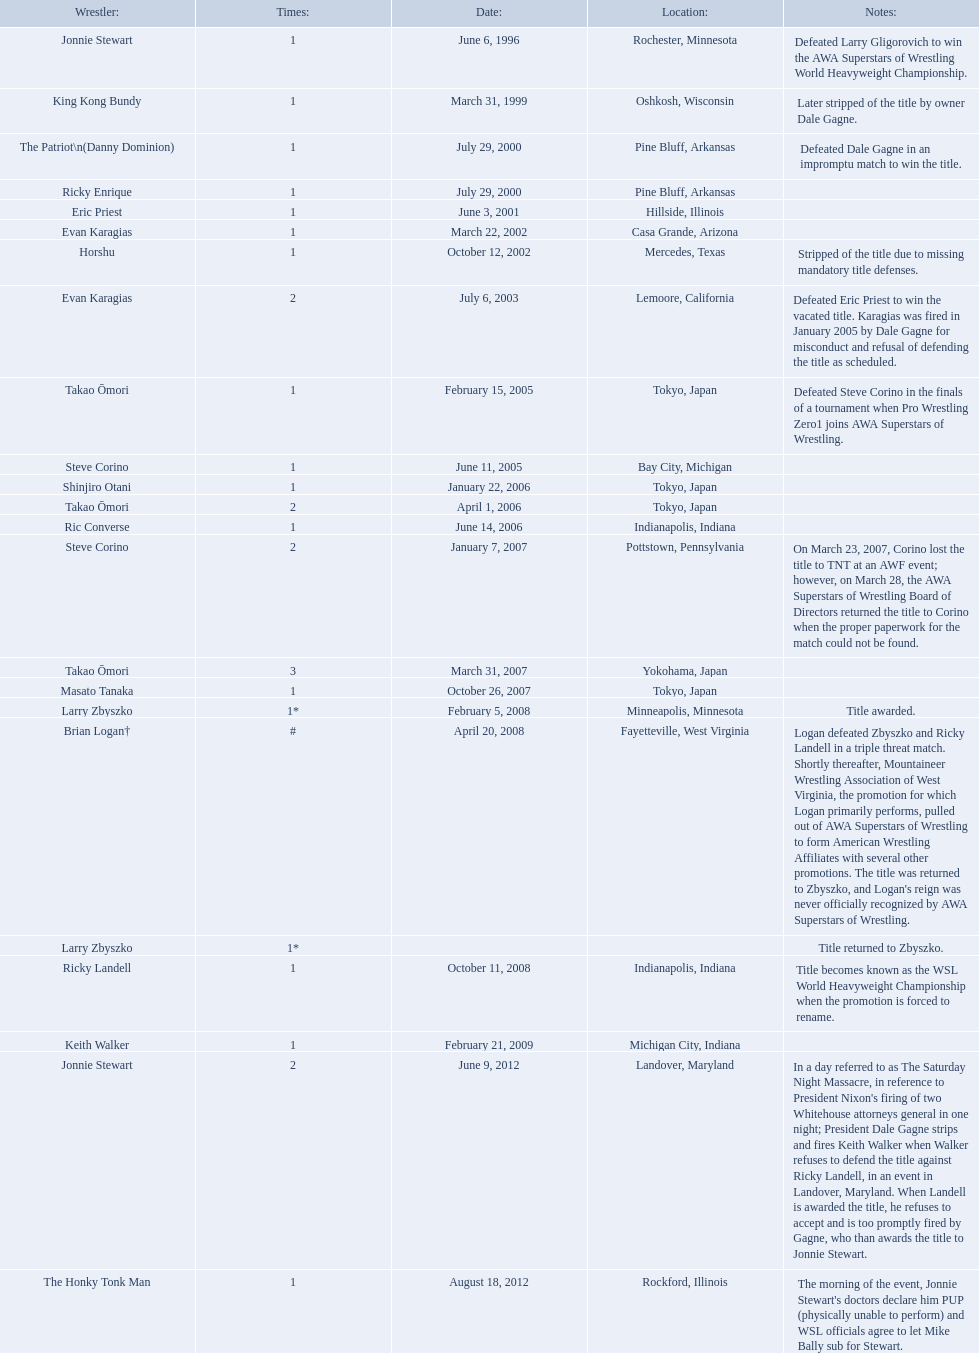Who are the wrestlers? Jonnie Stewart, Rochester, Minnesota, King Kong Bundy, Oshkosh, Wisconsin, The Patriot\n(Danny Dominion), Pine Bluff, Arkansas, Ricky Enrique, Pine Bluff, Arkansas, Eric Priest, Hillside, Illinois, Evan Karagias, Casa Grande, Arizona, Horshu, Mercedes, Texas, Evan Karagias, Lemoore, California, Takao Ōmori, Tokyo, Japan, Steve Corino, Bay City, Michigan, Shinjiro Otani, Tokyo, Japan, Takao Ōmori, Tokyo, Japan, Ric Converse, Indianapolis, Indiana, Steve Corino, Pottstown, Pennsylvania, Takao Ōmori, Yokohama, Japan, Masato Tanaka, Tokyo, Japan, Larry Zbyszko, Minneapolis, Minnesota, Brian Logan†, Fayetteville, West Virginia, Larry Zbyszko, , Ricky Landell, Indianapolis, Indiana, Keith Walker, Michigan City, Indiana, Jonnie Stewart, Landover, Maryland, The Honky Tonk Man, Rockford, Illinois. Who was from texas? Horshu, Mercedes, Texas. I'm looking to parse the entire table for insights. Could you assist me with that? {'header': ['Wrestler:', 'Times:', 'Date:', 'Location:', 'Notes:'], 'rows': [['Jonnie Stewart', '1', 'June 6, 1996', 'Rochester, Minnesota', 'Defeated Larry Gligorovich to win the AWA Superstars of Wrestling World Heavyweight Championship.'], ['King Kong Bundy', '1', 'March 31, 1999', 'Oshkosh, Wisconsin', 'Later stripped of the title by owner Dale Gagne.'], ['The Patriot\\n(Danny Dominion)', '1', 'July 29, 2000', 'Pine Bluff, Arkansas', 'Defeated Dale Gagne in an impromptu match to win the title.'], ['Ricky Enrique', '1', 'July 29, 2000', 'Pine Bluff, Arkansas', ''], ['Eric Priest', '1', 'June 3, 2001', 'Hillside, Illinois', ''], ['Evan Karagias', '1', 'March 22, 2002', 'Casa Grande, Arizona', ''], ['Horshu', '1', 'October 12, 2002', 'Mercedes, Texas', 'Stripped of the title due to missing mandatory title defenses.'], ['Evan Karagias', '2', 'July 6, 2003', 'Lemoore, California', 'Defeated Eric Priest to win the vacated title. Karagias was fired in January 2005 by Dale Gagne for misconduct and refusal of defending the title as scheduled.'], ['Takao Ōmori', '1', 'February 15, 2005', 'Tokyo, Japan', 'Defeated Steve Corino in the finals of a tournament when Pro Wrestling Zero1 joins AWA Superstars of Wrestling.'], ['Steve Corino', '1', 'June 11, 2005', 'Bay City, Michigan', ''], ['Shinjiro Otani', '1', 'January 22, 2006', 'Tokyo, Japan', ''], ['Takao Ōmori', '2', 'April 1, 2006', 'Tokyo, Japan', ''], ['Ric Converse', '1', 'June 14, 2006', 'Indianapolis, Indiana', ''], ['Steve Corino', '2', 'January 7, 2007', 'Pottstown, Pennsylvania', 'On March 23, 2007, Corino lost the title to TNT at an AWF event; however, on March 28, the AWA Superstars of Wrestling Board of Directors returned the title to Corino when the proper paperwork for the match could not be found.'], ['Takao Ōmori', '3', 'March 31, 2007', 'Yokohama, Japan', ''], ['Masato Tanaka', '1', 'October 26, 2007', 'Tokyo, Japan', ''], ['Larry Zbyszko', '1*', 'February 5, 2008', 'Minneapolis, Minnesota', 'Title awarded.'], ['Brian Logan†', '#', 'April 20, 2008', 'Fayetteville, West Virginia', "Logan defeated Zbyszko and Ricky Landell in a triple threat match. Shortly thereafter, Mountaineer Wrestling Association of West Virginia, the promotion for which Logan primarily performs, pulled out of AWA Superstars of Wrestling to form American Wrestling Affiliates with several other promotions. The title was returned to Zbyszko, and Logan's reign was never officially recognized by AWA Superstars of Wrestling."], ['Larry Zbyszko', '1*', '', '', 'Title returned to Zbyszko.'], ['Ricky Landell', '1', 'October 11, 2008', 'Indianapolis, Indiana', 'Title becomes known as the WSL World Heavyweight Championship when the promotion is forced to rename.'], ['Keith Walker', '1', 'February 21, 2009', 'Michigan City, Indiana', ''], ['Jonnie Stewart', '2', 'June 9, 2012', 'Landover, Maryland', "In a day referred to as The Saturday Night Massacre, in reference to President Nixon's firing of two Whitehouse attorneys general in one night; President Dale Gagne strips and fires Keith Walker when Walker refuses to defend the title against Ricky Landell, in an event in Landover, Maryland. When Landell is awarded the title, he refuses to accept and is too promptly fired by Gagne, who than awards the title to Jonnie Stewart."], ['The Honky Tonk Man', '1', 'August 18, 2012', 'Rockford, Illinois', "The morning of the event, Jonnie Stewart's doctors declare him PUP (physically unable to perform) and WSL officials agree to let Mike Bally sub for Stewart."]]} Who is he? Horshu. Who are the grapplers? Jonnie Stewart, Rochester, Minnesota, King Kong Bundy, Oshkosh, Wisconsin, The Patriot\n(Danny Dominion), Pine Bluff, Arkansas, Ricky Enrique, Pine Bluff, Arkansas, Eric Priest, Hillside, Illinois, Evan Karagias, Casa Grande, Arizona, Horshu, Mercedes, Texas, Evan Karagias, Lemoore, California, Takao Ōmori, Tokyo, Japan, Steve Corino, Bay City, Michigan, Shinjiro Otani, Tokyo, Japan, Takao Ōmori, Tokyo, Japan, Ric Converse, Indianapolis, Indiana, Steve Corino, Pottstown, Pennsylvania, Takao Ōmori, Yokohama, Japan, Masato Tanaka, Tokyo, Japan, Larry Zbyszko, Minneapolis, Minnesota, Brian Logan†, Fayetteville, West Virginia, Larry Zbyszko, , Ricky Landell, Indianapolis, Indiana, Keith Walker, Michigan City, Indiana, Jonnie Stewart, Landover, Maryland, The Honky Tonk Man, Rockford, Illinois. Who was from texas? Horshu, Mercedes, Texas. Who is he? Horshu. Who are the wrestling participants? Jonnie Stewart, Rochester, Minnesota, King Kong Bundy, Oshkosh, Wisconsin, The Patriot\n(Danny Dominion), Pine Bluff, Arkansas, Ricky Enrique, Pine Bluff, Arkansas, Eric Priest, Hillside, Illinois, Evan Karagias, Casa Grande, Arizona, Horshu, Mercedes, Texas, Evan Karagias, Lemoore, California, Takao Ōmori, Tokyo, Japan, Steve Corino, Bay City, Michigan, Shinjiro Otani, Tokyo, Japan, Takao Ōmori, Tokyo, Japan, Ric Converse, Indianapolis, Indiana, Steve Corino, Pottstown, Pennsylvania, Takao Ōmori, Yokohama, Japan, Masato Tanaka, Tokyo, Japan, Larry Zbyszko, Minneapolis, Minnesota, Brian Logan†, Fayetteville, West Virginia, Larry Zbyszko, , Ricky Landell, Indianapolis, Indiana, Keith Walker, Michigan City, Indiana, Jonnie Stewart, Landover, Maryland, The Honky Tonk Man, Rockford, Illinois. Who hailed from texas? Horshu, Mercedes, Texas. Who is the individual? Horshu. Who are the individuals involved in wrestling? Jonnie Stewart, Rochester, Minnesota, King Kong Bundy, Oshkosh, Wisconsin, The Patriot\n(Danny Dominion), Pine Bluff, Arkansas, Ricky Enrique, Pine Bluff, Arkansas, Eric Priest, Hillside, Illinois, Evan Karagias, Casa Grande, Arizona, Horshu, Mercedes, Texas, Evan Karagias, Lemoore, California, Takao Ōmori, Tokyo, Japan, Steve Corino, Bay City, Michigan, Shinjiro Otani, Tokyo, Japan, Takao Ōmori, Tokyo, Japan, Ric Converse, Indianapolis, Indiana, Steve Corino, Pottstown, Pennsylvania, Takao Ōmori, Yokohama, Japan, Masato Tanaka, Tokyo, Japan, Larry Zbyszko, Minneapolis, Minnesota, Brian Logan†, Fayetteville, West Virginia, Larry Zbyszko, , Ricky Landell, Indianapolis, Indiana, Keith Walker, Michigan City, Indiana, Jonnie Stewart, Landover, Maryland, The Honky Tonk Man, Rockford, Illinois. Which person hails from texas? Horshu, Mercedes, Texas. Who might this person be? Horshu. Who might the wrestlers be? Jonnie Stewart, Rochester, Minnesota, King Kong Bundy, Oshkosh, Wisconsin, The Patriot\n(Danny Dominion), Pine Bluff, Arkansas, Ricky Enrique, Pine Bluff, Arkansas, Eric Priest, Hillside, Illinois, Evan Karagias, Casa Grande, Arizona, Horshu, Mercedes, Texas, Evan Karagias, Lemoore, California, Takao Ōmori, Tokyo, Japan, Steve Corino, Bay City, Michigan, Shinjiro Otani, Tokyo, Japan, Takao Ōmori, Tokyo, Japan, Ric Converse, Indianapolis, Indiana, Steve Corino, Pottstown, Pennsylvania, Takao Ōmori, Yokohama, Japan, Masato Tanaka, Tokyo, Japan, Larry Zbyszko, Minneapolis, Minnesota, Brian Logan†, Fayetteville, West Virginia, Larry Zbyszko, , Ricky Landell, Indianapolis, Indiana, Keith Walker, Michigan City, Indiana, Jonnie Stewart, Landover, Maryland, The Honky Tonk Man, Rockford, Illinois. Who has texas origins? Horshu, Mercedes, Texas. Who is this person in question? Horshu. From where do the title holders originate? Rochester, Minnesota, Oshkosh, Wisconsin, Pine Bluff, Arkansas, Pine Bluff, Arkansas, Hillside, Illinois, Casa Grande, Arizona, Mercedes, Texas, Lemoore, California, Tokyo, Japan, Bay City, Michigan, Tokyo, Japan, Tokyo, Japan, Indianapolis, Indiana, Pottstown, Pennsylvania, Yokohama, Japan, Tokyo, Japan, Minneapolis, Minnesota, Fayetteville, West Virginia, , Indianapolis, Indiana, Michigan City, Indiana, Landover, Maryland, Rockford, Illinois. Who is the title holder hailing from texas? Horshu. What is the origin of the title holders? Rochester, Minnesota, Oshkosh, Wisconsin, Pine Bluff, Arkansas, Pine Bluff, Arkansas, Hillside, Illinois, Casa Grande, Arizona, Mercedes, Texas, Lemoore, California, Tokyo, Japan, Bay City, Michigan, Tokyo, Japan, Tokyo, Japan, Indianapolis, Indiana, Pottstown, Pennsylvania, Yokohama, Japan, Tokyo, Japan, Minneapolis, Minnesota, Fayetteville, West Virginia, , Indianapolis, Indiana, Michigan City, Indiana, Landover, Maryland, Rockford, Illinois. Can you identify the title holder belonging to texas? Horshu. Where do the title holders come from? Rochester, Minnesota, Oshkosh, Wisconsin, Pine Bluff, Arkansas, Pine Bluff, Arkansas, Hillside, Illinois, Casa Grande, Arizona, Mercedes, Texas, Lemoore, California, Tokyo, Japan, Bay City, Michigan, Tokyo, Japan, Tokyo, Japan, Indianapolis, Indiana, Pottstown, Pennsylvania, Yokohama, Japan, Tokyo, Japan, Minneapolis, Minnesota, Fayetteville, West Virginia, , Indianapolis, Indiana, Michigan City, Indiana, Landover, Maryland, Rockford, Illinois. Who is the individual holding a title from texas? Horshu. 